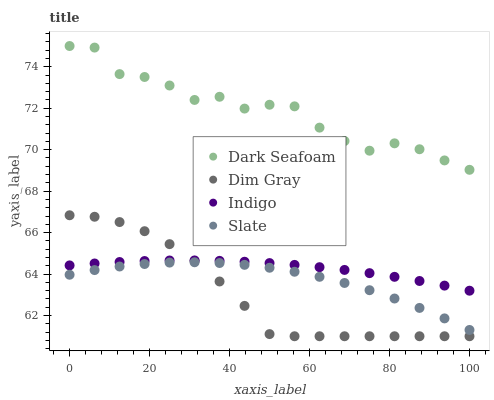Does Dim Gray have the minimum area under the curve?
Answer yes or no. Yes. Does Dark Seafoam have the maximum area under the curve?
Answer yes or no. Yes. Does Indigo have the minimum area under the curve?
Answer yes or no. No. Does Indigo have the maximum area under the curve?
Answer yes or no. No. Is Indigo the smoothest?
Answer yes or no. Yes. Is Dark Seafoam the roughest?
Answer yes or no. Yes. Is Dim Gray the smoothest?
Answer yes or no. No. Is Dim Gray the roughest?
Answer yes or no. No. Does Dim Gray have the lowest value?
Answer yes or no. Yes. Does Indigo have the lowest value?
Answer yes or no. No. Does Dark Seafoam have the highest value?
Answer yes or no. Yes. Does Dim Gray have the highest value?
Answer yes or no. No. Is Slate less than Indigo?
Answer yes or no. Yes. Is Dark Seafoam greater than Dim Gray?
Answer yes or no. Yes. Does Slate intersect Dim Gray?
Answer yes or no. Yes. Is Slate less than Dim Gray?
Answer yes or no. No. Is Slate greater than Dim Gray?
Answer yes or no. No. Does Slate intersect Indigo?
Answer yes or no. No. 